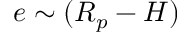Convert formula to latex. <formula><loc_0><loc_0><loc_500><loc_500>e \sim ( R _ { p } - H )</formula> 